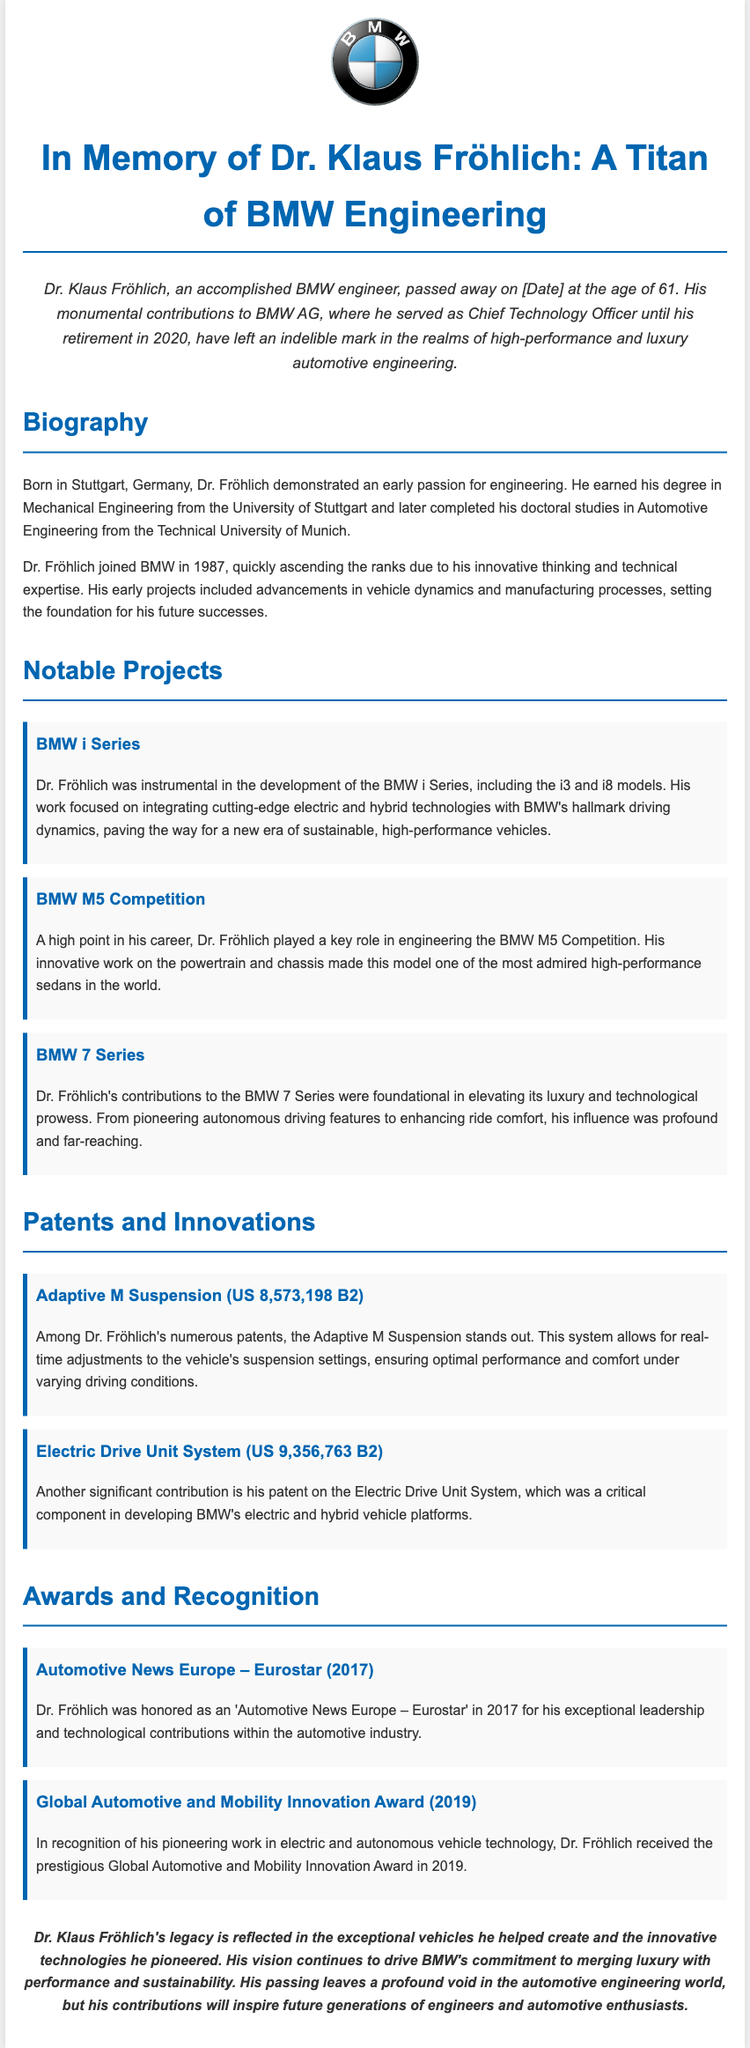What was Dr. Klaus Fröhlich's age at the time of passing? The document states that Dr. Fröhlich passed away at the age of 61.
Answer: 61 What title did Dr. Klaus Fröhlich hold until his retirement? The document mentions that he served as Chief Technology Officer until his retirement in 2020.
Answer: Chief Technology Officer Which two models were mentioned in relation to the BMW i Series? The document specifically names the i3 and i8 models as part of the BMW i Series development.
Answer: i3 and i8 What year did Dr. Fröhlich receive the Eurostar award? The award was received in 2017, as noted in the awards section of the document.
Answer: 2017 Which significant suspension system patent is mentioned? The Adaptive M Suspension patent (US 8,573,198 B2) is highlighted in the patents section.
Answer: Adaptive M Suspension In which city was Dr. Klaus Fröhlich born? The document indicates that he was born in Stuttgart, Germany.
Answer: Stuttgart What type of vehicle did the BMW M5 Competition embody? The document describes the BMW M5 Competition as one of the most admired high-performance sedans in the world.
Answer: High-performance sedan What was a major focus of Dr. Fröhlich's work on the BMW 7 Series? His contributions focused on pioneering autonomous driving features and enhancing ride comfort.
Answer: Autonomous driving features What is part of Dr. Fröhlich's legacy according to the document? The legacy mentioned includes exceptional vehicles and innovative technologies he pioneered.
Answer: Exceptional vehicles and innovative technologies 